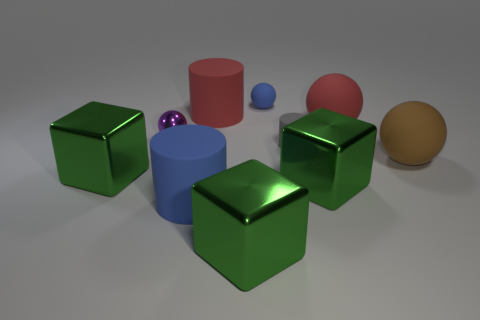Is the color of the metallic ball the same as the tiny rubber cylinder?
Provide a short and direct response. No. There is a cylinder left of the large red rubber object on the left side of the big matte sphere behind the tiny gray object; how big is it?
Your answer should be compact. Large. There is a small sphere to the right of the small metal ball; is its color the same as the tiny cylinder?
Offer a very short reply. No. What is the size of the brown matte thing that is the same shape as the tiny purple thing?
Your answer should be very brief. Large. How many objects are either gray objects on the right side of the purple sphere or big red matte things behind the brown thing?
Provide a succinct answer. 3. What shape is the red thing that is behind the red matte sphere on the right side of the tiny shiny object?
Your answer should be very brief. Cylinder. Is there any other thing that is the same color as the tiny matte ball?
Your response must be concise. Yes. Is there anything else that has the same size as the blue rubber cylinder?
Provide a succinct answer. Yes. What number of objects are big blue matte objects or rubber balls?
Your answer should be very brief. 4. Are there any blue things that have the same size as the gray thing?
Keep it short and to the point. Yes. 